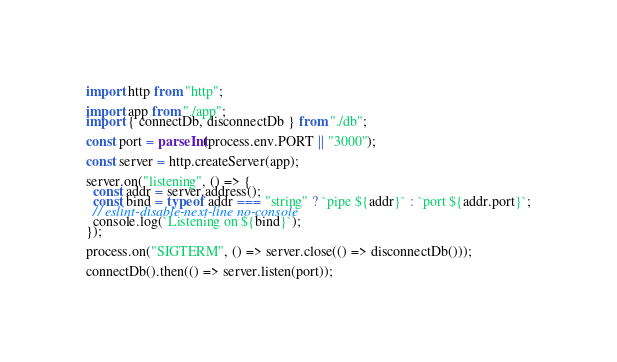<code> <loc_0><loc_0><loc_500><loc_500><_JavaScript_>import http from "http";

import app from "./app";
import { connectDb, disconnectDb } from "./db";

const port = parseInt(process.env.PORT || "3000");

const server = http.createServer(app);

server.on("listening", () => {
  const addr = server.address();
  const bind = typeof addr === "string" ? `pipe ${addr}` : `port ${addr.port}`;
  // eslint-disable-next-line no-console
  console.log(`Listening on ${bind}`);
});

process.on("SIGTERM", () => server.close(() => disconnectDb()));

connectDb().then(() => server.listen(port));
</code> 